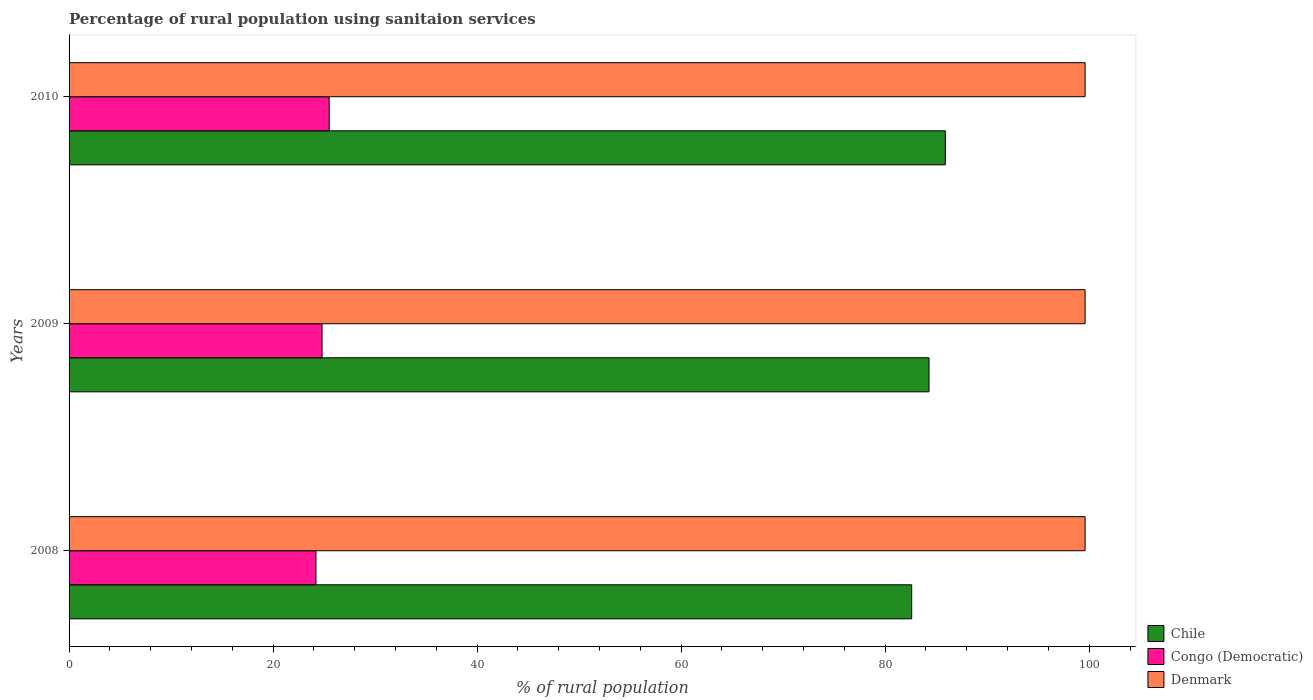How many different coloured bars are there?
Your response must be concise. 3. Are the number of bars per tick equal to the number of legend labels?
Ensure brevity in your answer.  Yes. Are the number of bars on each tick of the Y-axis equal?
Offer a very short reply. Yes. In how many cases, is the number of bars for a given year not equal to the number of legend labels?
Your answer should be very brief. 0. What is the percentage of rural population using sanitaion services in Denmark in 2008?
Your answer should be compact. 99.6. Across all years, what is the maximum percentage of rural population using sanitaion services in Congo (Democratic)?
Give a very brief answer. 25.5. Across all years, what is the minimum percentage of rural population using sanitaion services in Denmark?
Give a very brief answer. 99.6. In which year was the percentage of rural population using sanitaion services in Congo (Democratic) maximum?
Your response must be concise. 2010. In which year was the percentage of rural population using sanitaion services in Congo (Democratic) minimum?
Provide a short and direct response. 2008. What is the total percentage of rural population using sanitaion services in Denmark in the graph?
Your response must be concise. 298.8. What is the difference between the percentage of rural population using sanitaion services in Denmark in 2008 and that in 2009?
Offer a very short reply. 0. What is the difference between the percentage of rural population using sanitaion services in Congo (Democratic) in 2010 and the percentage of rural population using sanitaion services in Chile in 2009?
Keep it short and to the point. -58.8. What is the average percentage of rural population using sanitaion services in Congo (Democratic) per year?
Your answer should be compact. 24.83. In the year 2008, what is the difference between the percentage of rural population using sanitaion services in Denmark and percentage of rural population using sanitaion services in Congo (Democratic)?
Keep it short and to the point. 75.4. Is the percentage of rural population using sanitaion services in Denmark in 2009 less than that in 2010?
Ensure brevity in your answer.  No. Is the difference between the percentage of rural population using sanitaion services in Denmark in 2008 and 2009 greater than the difference between the percentage of rural population using sanitaion services in Congo (Democratic) in 2008 and 2009?
Your response must be concise. Yes. What is the difference between the highest and the second highest percentage of rural population using sanitaion services in Chile?
Your answer should be very brief. 1.6. What is the difference between the highest and the lowest percentage of rural population using sanitaion services in Congo (Democratic)?
Your answer should be compact. 1.3. In how many years, is the percentage of rural population using sanitaion services in Chile greater than the average percentage of rural population using sanitaion services in Chile taken over all years?
Give a very brief answer. 2. What does the 1st bar from the bottom in 2009 represents?
Give a very brief answer. Chile. Is it the case that in every year, the sum of the percentage of rural population using sanitaion services in Chile and percentage of rural population using sanitaion services in Denmark is greater than the percentage of rural population using sanitaion services in Congo (Democratic)?
Make the answer very short. Yes. How many bars are there?
Offer a very short reply. 9. What is the difference between two consecutive major ticks on the X-axis?
Provide a succinct answer. 20. Are the values on the major ticks of X-axis written in scientific E-notation?
Your answer should be very brief. No. Where does the legend appear in the graph?
Offer a terse response. Bottom right. How are the legend labels stacked?
Offer a very short reply. Vertical. What is the title of the graph?
Provide a succinct answer. Percentage of rural population using sanitaion services. Does "United Kingdom" appear as one of the legend labels in the graph?
Keep it short and to the point. No. What is the label or title of the X-axis?
Provide a succinct answer. % of rural population. What is the % of rural population of Chile in 2008?
Your answer should be compact. 82.6. What is the % of rural population of Congo (Democratic) in 2008?
Your answer should be compact. 24.2. What is the % of rural population in Denmark in 2008?
Your answer should be compact. 99.6. What is the % of rural population in Chile in 2009?
Provide a short and direct response. 84.3. What is the % of rural population of Congo (Democratic) in 2009?
Your response must be concise. 24.8. What is the % of rural population in Denmark in 2009?
Give a very brief answer. 99.6. What is the % of rural population of Chile in 2010?
Give a very brief answer. 85.9. What is the % of rural population of Denmark in 2010?
Provide a succinct answer. 99.6. Across all years, what is the maximum % of rural population of Chile?
Your answer should be compact. 85.9. Across all years, what is the maximum % of rural population of Denmark?
Provide a succinct answer. 99.6. Across all years, what is the minimum % of rural population of Chile?
Your response must be concise. 82.6. Across all years, what is the minimum % of rural population of Congo (Democratic)?
Provide a succinct answer. 24.2. Across all years, what is the minimum % of rural population of Denmark?
Keep it short and to the point. 99.6. What is the total % of rural population in Chile in the graph?
Provide a short and direct response. 252.8. What is the total % of rural population of Congo (Democratic) in the graph?
Your response must be concise. 74.5. What is the total % of rural population in Denmark in the graph?
Offer a terse response. 298.8. What is the difference between the % of rural population in Congo (Democratic) in 2008 and that in 2010?
Offer a very short reply. -1.3. What is the difference between the % of rural population in Chile in 2009 and that in 2010?
Give a very brief answer. -1.6. What is the difference between the % of rural population in Congo (Democratic) in 2009 and that in 2010?
Make the answer very short. -0.7. What is the difference between the % of rural population in Denmark in 2009 and that in 2010?
Make the answer very short. 0. What is the difference between the % of rural population of Chile in 2008 and the % of rural population of Congo (Democratic) in 2009?
Your answer should be compact. 57.8. What is the difference between the % of rural population of Congo (Democratic) in 2008 and the % of rural population of Denmark in 2009?
Offer a terse response. -75.4. What is the difference between the % of rural population of Chile in 2008 and the % of rural population of Congo (Democratic) in 2010?
Make the answer very short. 57.1. What is the difference between the % of rural population of Congo (Democratic) in 2008 and the % of rural population of Denmark in 2010?
Keep it short and to the point. -75.4. What is the difference between the % of rural population in Chile in 2009 and the % of rural population in Congo (Democratic) in 2010?
Your response must be concise. 58.8. What is the difference between the % of rural population in Chile in 2009 and the % of rural population in Denmark in 2010?
Your answer should be very brief. -15.3. What is the difference between the % of rural population of Congo (Democratic) in 2009 and the % of rural population of Denmark in 2010?
Offer a very short reply. -74.8. What is the average % of rural population of Chile per year?
Offer a terse response. 84.27. What is the average % of rural population of Congo (Democratic) per year?
Provide a short and direct response. 24.83. What is the average % of rural population in Denmark per year?
Give a very brief answer. 99.6. In the year 2008, what is the difference between the % of rural population in Chile and % of rural population in Congo (Democratic)?
Provide a short and direct response. 58.4. In the year 2008, what is the difference between the % of rural population of Congo (Democratic) and % of rural population of Denmark?
Your answer should be compact. -75.4. In the year 2009, what is the difference between the % of rural population in Chile and % of rural population in Congo (Democratic)?
Offer a very short reply. 59.5. In the year 2009, what is the difference between the % of rural population in Chile and % of rural population in Denmark?
Make the answer very short. -15.3. In the year 2009, what is the difference between the % of rural population in Congo (Democratic) and % of rural population in Denmark?
Provide a succinct answer. -74.8. In the year 2010, what is the difference between the % of rural population of Chile and % of rural population of Congo (Democratic)?
Offer a very short reply. 60.4. In the year 2010, what is the difference between the % of rural population of Chile and % of rural population of Denmark?
Keep it short and to the point. -13.7. In the year 2010, what is the difference between the % of rural population in Congo (Democratic) and % of rural population in Denmark?
Give a very brief answer. -74.1. What is the ratio of the % of rural population in Chile in 2008 to that in 2009?
Provide a succinct answer. 0.98. What is the ratio of the % of rural population of Congo (Democratic) in 2008 to that in 2009?
Your answer should be compact. 0.98. What is the ratio of the % of rural population in Chile in 2008 to that in 2010?
Provide a succinct answer. 0.96. What is the ratio of the % of rural population in Congo (Democratic) in 2008 to that in 2010?
Keep it short and to the point. 0.95. What is the ratio of the % of rural population of Chile in 2009 to that in 2010?
Provide a short and direct response. 0.98. What is the ratio of the % of rural population in Congo (Democratic) in 2009 to that in 2010?
Make the answer very short. 0.97. What is the difference between the highest and the second highest % of rural population of Chile?
Provide a short and direct response. 1.6. What is the difference between the highest and the second highest % of rural population of Congo (Democratic)?
Keep it short and to the point. 0.7. What is the difference between the highest and the second highest % of rural population in Denmark?
Ensure brevity in your answer.  0. What is the difference between the highest and the lowest % of rural population of Denmark?
Provide a succinct answer. 0. 